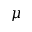<formula> <loc_0><loc_0><loc_500><loc_500>\mu</formula> 